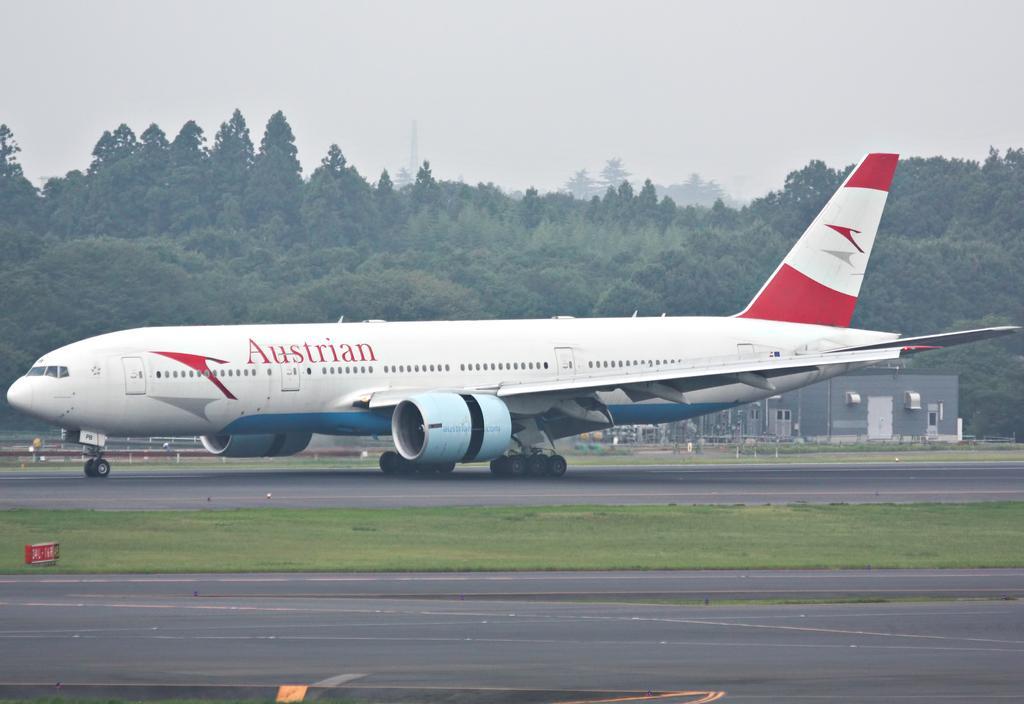How would you summarize this image in a sentence or two? In the foreground of this image, there is the road, in the background, there is an airplane moving on the run way and there is also the grass. In the background, there are trees, a tower, a room and the foggy sky. 